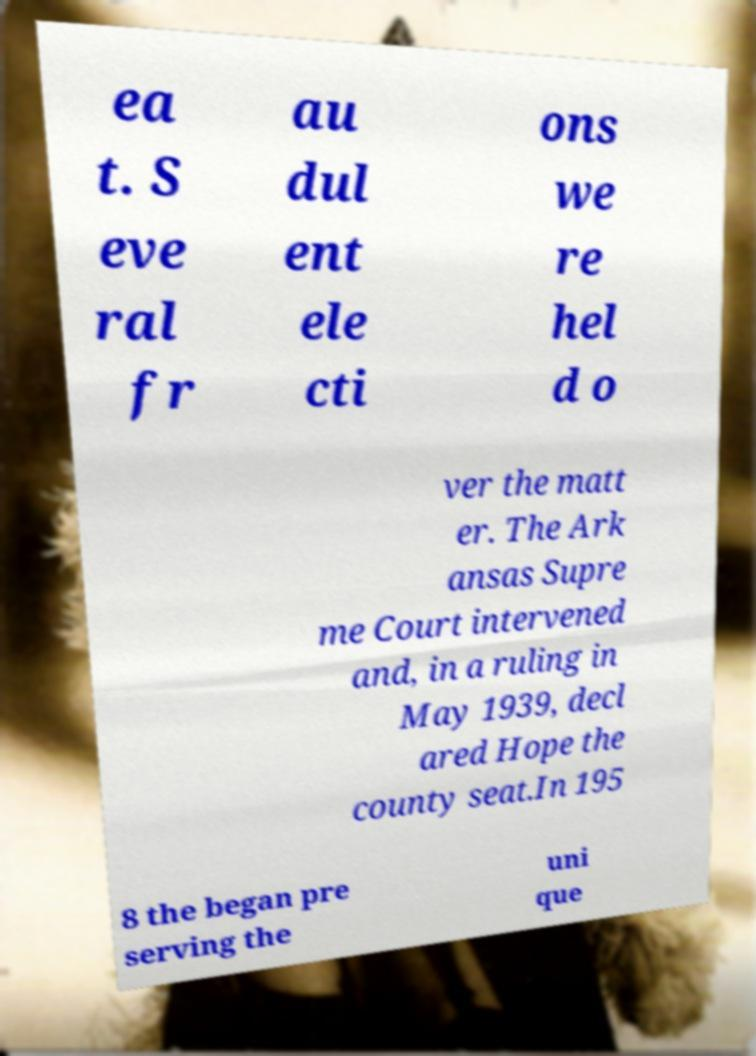Please identify and transcribe the text found in this image. ea t. S eve ral fr au dul ent ele cti ons we re hel d o ver the matt er. The Ark ansas Supre me Court intervened and, in a ruling in May 1939, decl ared Hope the county seat.In 195 8 the began pre serving the uni que 